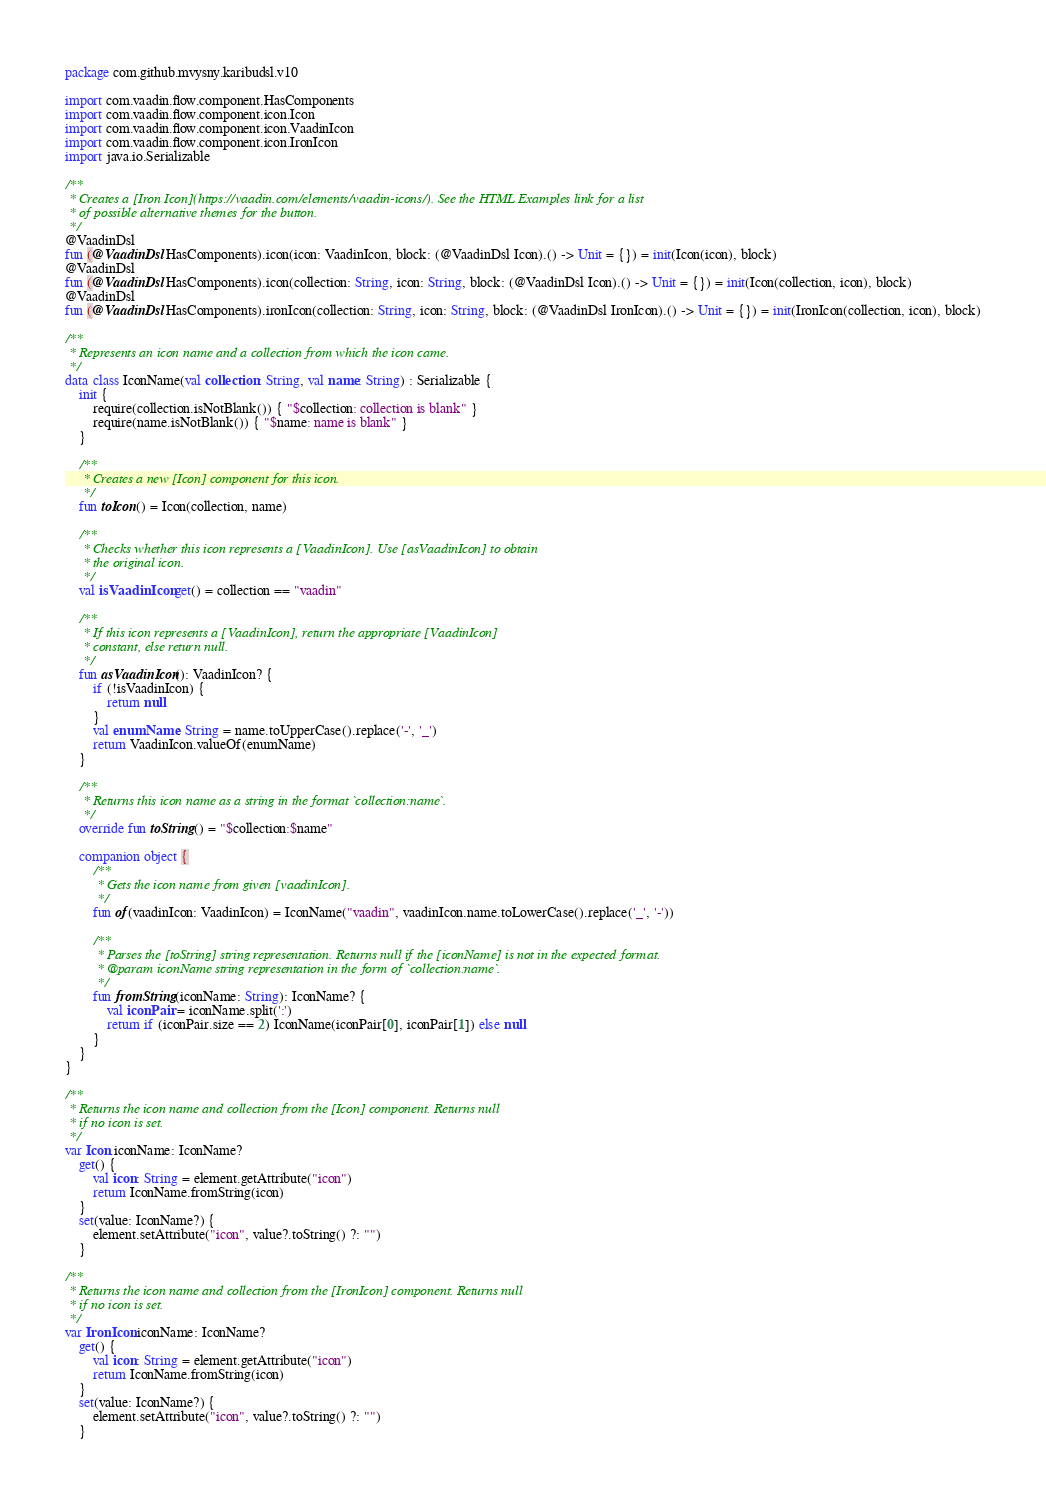<code> <loc_0><loc_0><loc_500><loc_500><_Kotlin_>package com.github.mvysny.karibudsl.v10

import com.vaadin.flow.component.HasComponents
import com.vaadin.flow.component.icon.Icon
import com.vaadin.flow.component.icon.VaadinIcon
import com.vaadin.flow.component.icon.IronIcon
import java.io.Serializable

/**
 * Creates a [Iron Icon](https://vaadin.com/elements/vaadin-icons/). See the HTML Examples link for a list
 * of possible alternative themes for the button.
 */
@VaadinDsl
fun (@VaadinDsl HasComponents).icon(icon: VaadinIcon, block: (@VaadinDsl Icon).() -> Unit = {}) = init(Icon(icon), block)
@VaadinDsl
fun (@VaadinDsl HasComponents).icon(collection: String, icon: String, block: (@VaadinDsl Icon).() -> Unit = {}) = init(Icon(collection, icon), block)
@VaadinDsl
fun (@VaadinDsl HasComponents).ironIcon(collection: String, icon: String, block: (@VaadinDsl IronIcon).() -> Unit = {}) = init(IronIcon(collection, icon), block)

/**
 * Represents an icon name and a collection from which the icon came.
 */
data class IconName(val collection: String, val name: String) : Serializable {
    init {
        require(collection.isNotBlank()) { "$collection: collection is blank" }
        require(name.isNotBlank()) { "$name: name is blank" }
    }

    /**
     * Creates a new [Icon] component for this icon.
     */
    fun toIcon() = Icon(collection, name)

    /**
     * Checks whether this icon represents a [VaadinIcon]. Use [asVaadinIcon] to obtain
     * the original icon.
     */
    val isVaadinIcon get() = collection == "vaadin"

    /**
     * If this icon represents a [VaadinIcon], return the appropriate [VaadinIcon]
     * constant, else return null.
     */
    fun asVaadinIcon(): VaadinIcon? {
        if (!isVaadinIcon) {
            return null
        }
        val enumName: String = name.toUpperCase().replace('-', '_')
        return VaadinIcon.valueOf(enumName)
    }

    /**
     * Returns this icon name as a string in the format `collection:name`.
     */
    override fun toString() = "$collection:$name"

    companion object {
        /**
         * Gets the icon name from given [vaadinIcon].
         */
        fun of(vaadinIcon: VaadinIcon) = IconName("vaadin", vaadinIcon.name.toLowerCase().replace('_', '-'))

        /**
         * Parses the [toString] string representation. Returns null if the [iconName] is not in the expected format.
         * @param iconName string representation in the form of `collection:name`.
         */
        fun fromString(iconName: String): IconName? {
            val iconPair = iconName.split(':')
            return if (iconPair.size == 2) IconName(iconPair[0], iconPair[1]) else null
        }
    }
}

/**
 * Returns the icon name and collection from the [Icon] component. Returns null
 * if no icon is set.
 */
var Icon.iconName: IconName?
    get() {
        val icon: String = element.getAttribute("icon")
        return IconName.fromString(icon)
    }
    set(value: IconName?) {
        element.setAttribute("icon", value?.toString() ?: "")
    }

/**
 * Returns the icon name and collection from the [IronIcon] component. Returns null
 * if no icon is set.
 */
var IronIcon.iconName: IconName?
    get() {
        val icon: String = element.getAttribute("icon")
        return IconName.fromString(icon)
    }
    set(value: IconName?) {
        element.setAttribute("icon", value?.toString() ?: "")
    }
</code> 